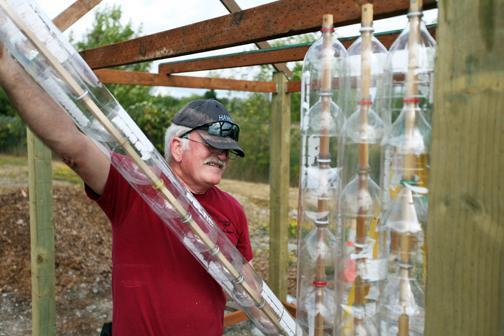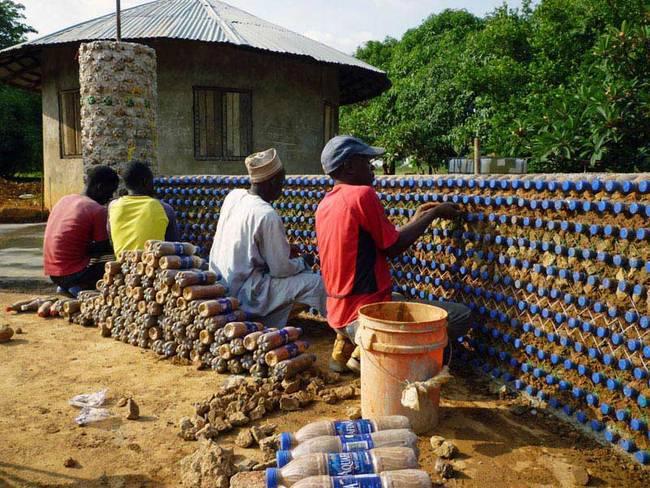The first image is the image on the left, the second image is the image on the right. Assess this claim about the two images: "Both images contain walls made of bottles.". Correct or not? Answer yes or no. Yes. 